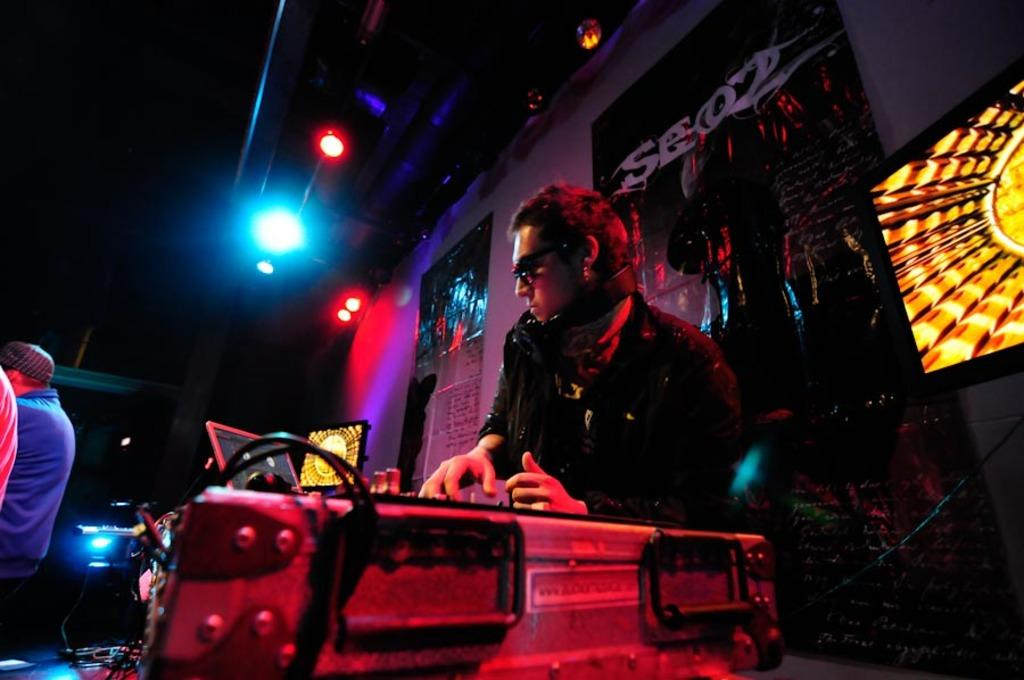Who or what is present in the image? There are people in the image. What can be seen above the people in the image? There are lights on top in the image. What is on the wall in the image? There are posters on the wall in the image. What type of ship is sailing in the background of the image? There is no ship present in the image; it only features people, lights, and posters. 